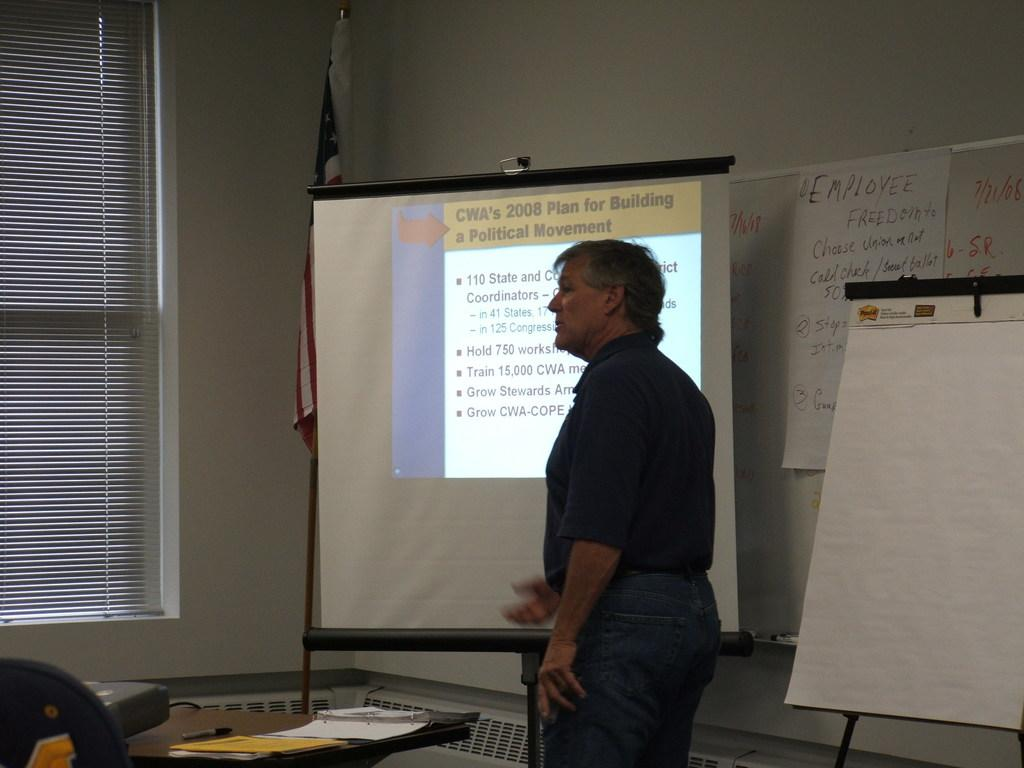<image>
Create a compact narrative representing the image presented. A screen is being used to show plans for building a political movement. 